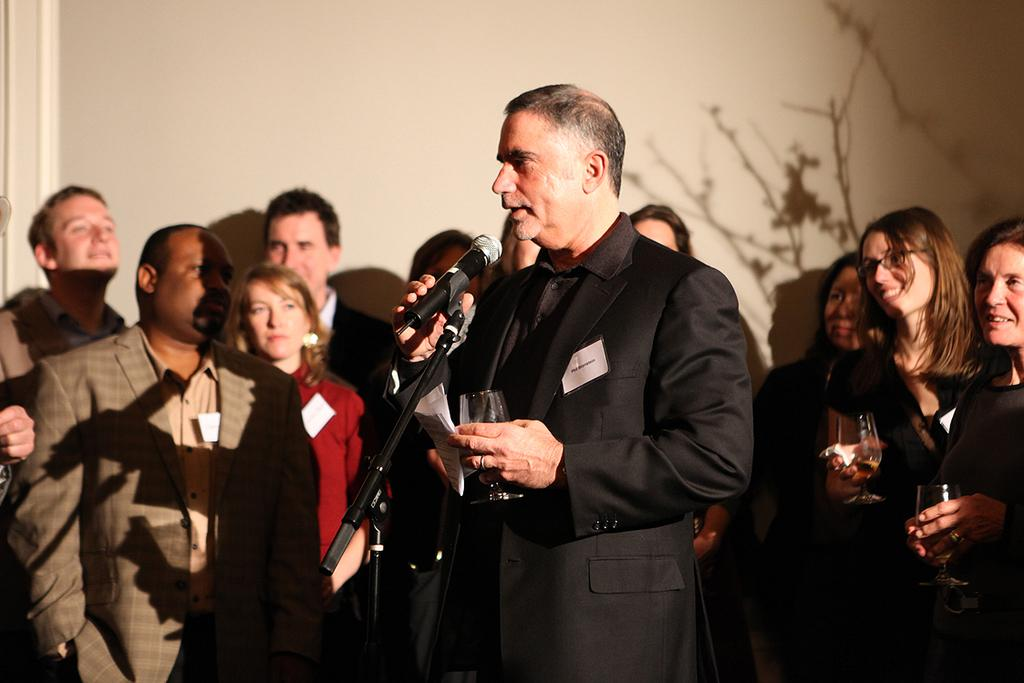How many people are in the image? There is a group of people in the image. What are the people in the image doing? The people are standing. Is there a specific person in the group who stands out? Yes, there is a person in the center of the group. What is the person in the center holding? The person in the center is holding a mic and a glass. What type of transport is being used by the people in the image? There is no transport visible in the image; it only shows a group of people standing. What subject is the person in the center teaching in the image? There is no indication in the image that the person in the center is teaching a subject. 